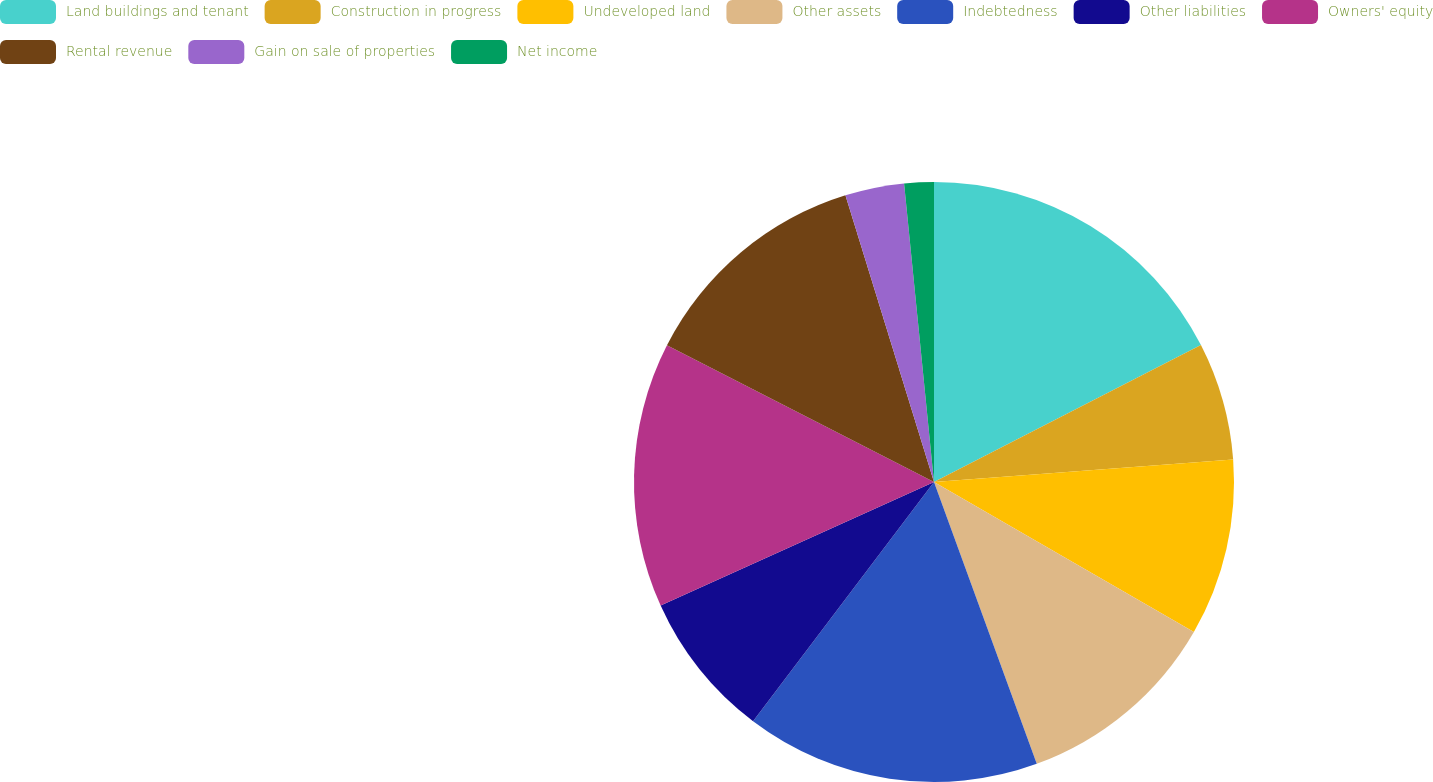Convert chart. <chart><loc_0><loc_0><loc_500><loc_500><pie_chart><fcel>Land buildings and tenant<fcel>Construction in progress<fcel>Undeveloped land<fcel>Other assets<fcel>Indebtedness<fcel>Other liabilities<fcel>Owners' equity<fcel>Rental revenue<fcel>Gain on sale of properties<fcel>Net income<nl><fcel>17.46%<fcel>6.35%<fcel>9.52%<fcel>11.11%<fcel>15.87%<fcel>7.94%<fcel>14.29%<fcel>12.7%<fcel>3.18%<fcel>1.59%<nl></chart> 